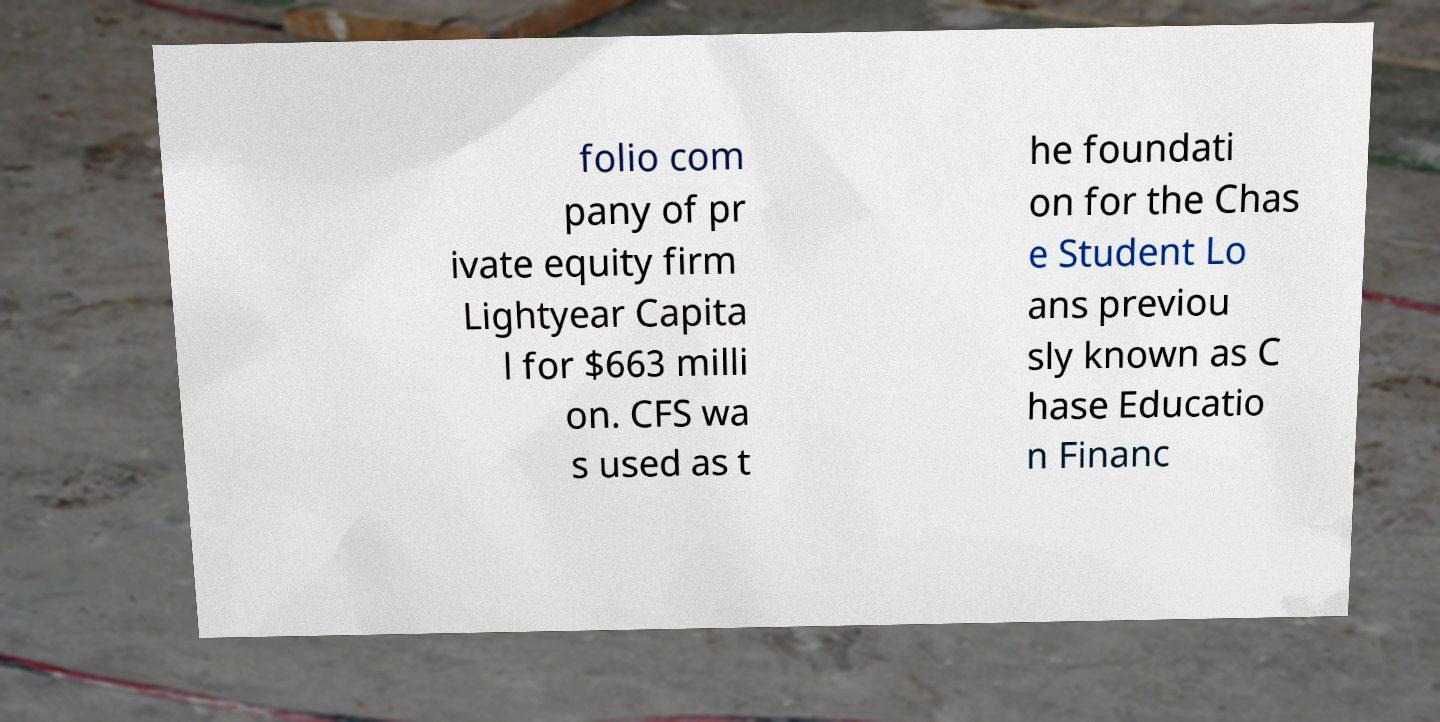Could you assist in decoding the text presented in this image and type it out clearly? folio com pany of pr ivate equity firm Lightyear Capita l for $663 milli on. CFS wa s used as t he foundati on for the Chas e Student Lo ans previou sly known as C hase Educatio n Financ 